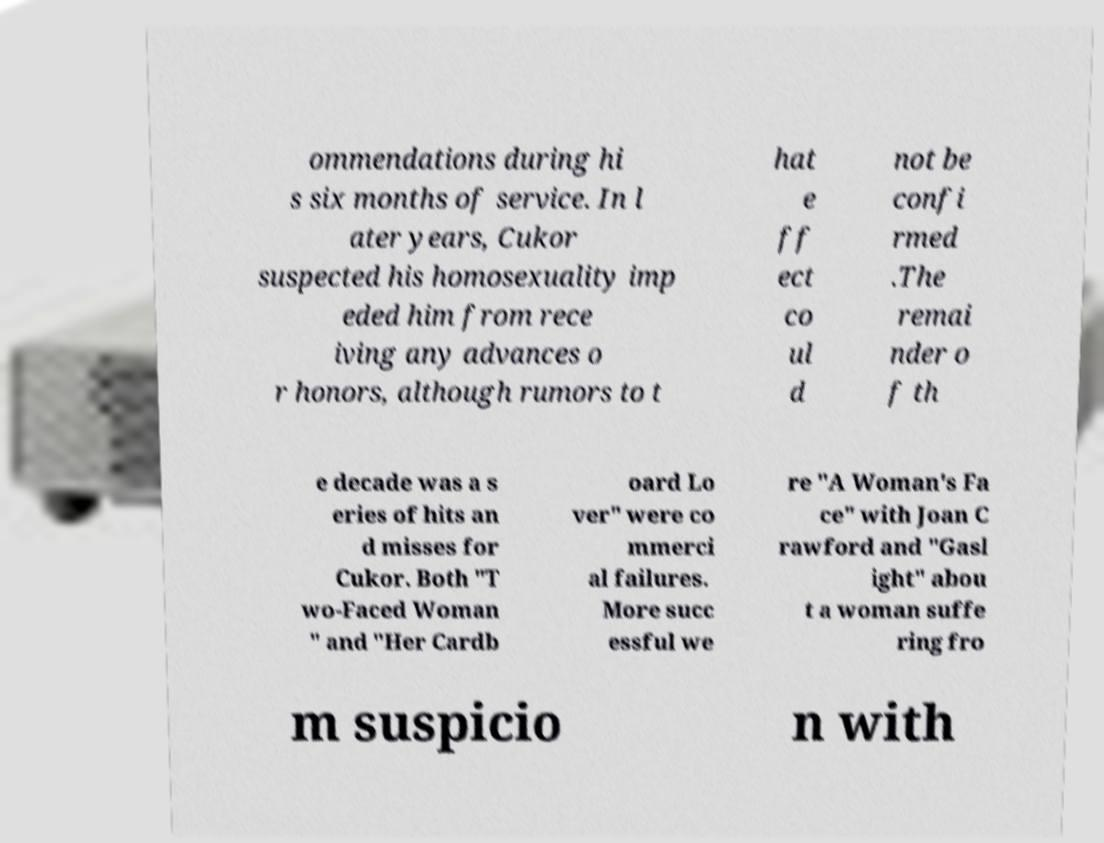Can you read and provide the text displayed in the image?This photo seems to have some interesting text. Can you extract and type it out for me? ommendations during hi s six months of service. In l ater years, Cukor suspected his homosexuality imp eded him from rece iving any advances o r honors, although rumors to t hat e ff ect co ul d not be confi rmed .The remai nder o f th e decade was a s eries of hits an d misses for Cukor. Both "T wo-Faced Woman " and "Her Cardb oard Lo ver" were co mmerci al failures. More succ essful we re "A Woman's Fa ce" with Joan C rawford and "Gasl ight" abou t a woman suffe ring fro m suspicio n with 